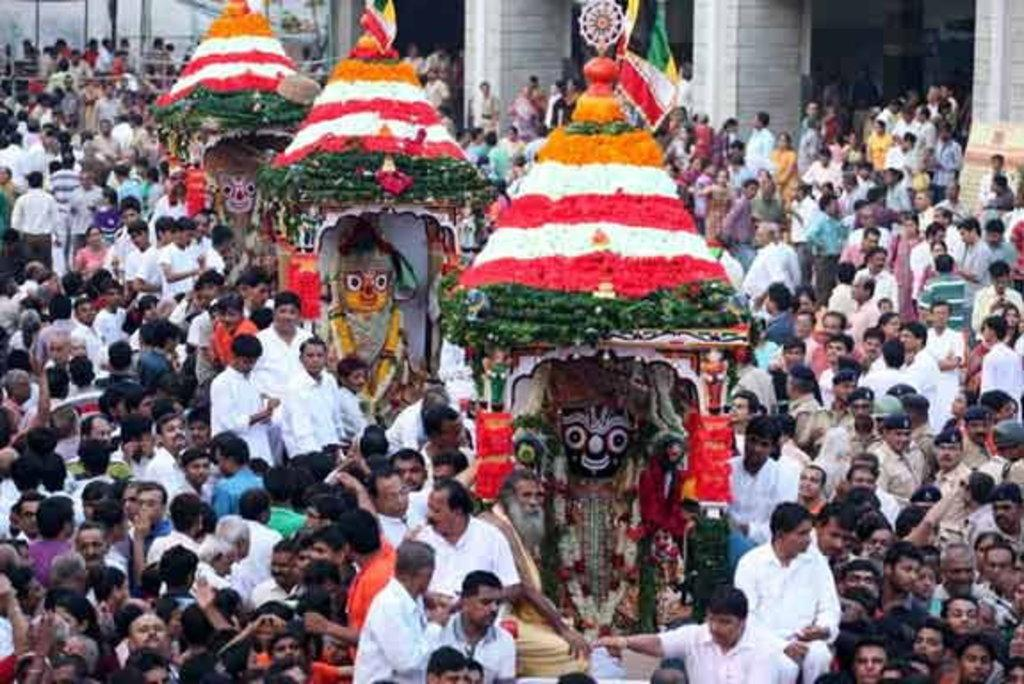What is the main subject of the image? There is a group of people in the image. What other objects or structures can be seen in the image? There are statues and flags in the image. What architectural features are visible in the background of the image? There are pillars visible in the background of the image. What type of knife is being used by the bears in the image? There are no bears or knives present in the image. 